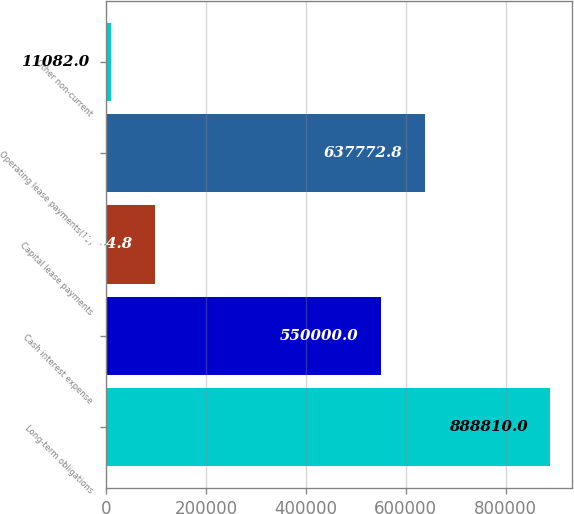Convert chart to OTSL. <chart><loc_0><loc_0><loc_500><loc_500><bar_chart><fcel>Long-term obligations<fcel>Cash interest expense<fcel>Capital lease payments<fcel>Operating lease payments(11)<fcel>Other non-current<nl><fcel>888810<fcel>550000<fcel>98854.8<fcel>637773<fcel>11082<nl></chart> 